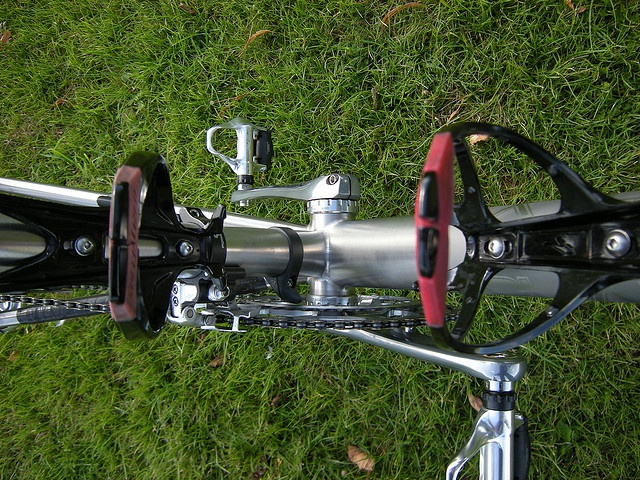Describe the objects in this image and their specific colors. I can see a bicycle in black, gray, white, and darkgray tones in this image. 